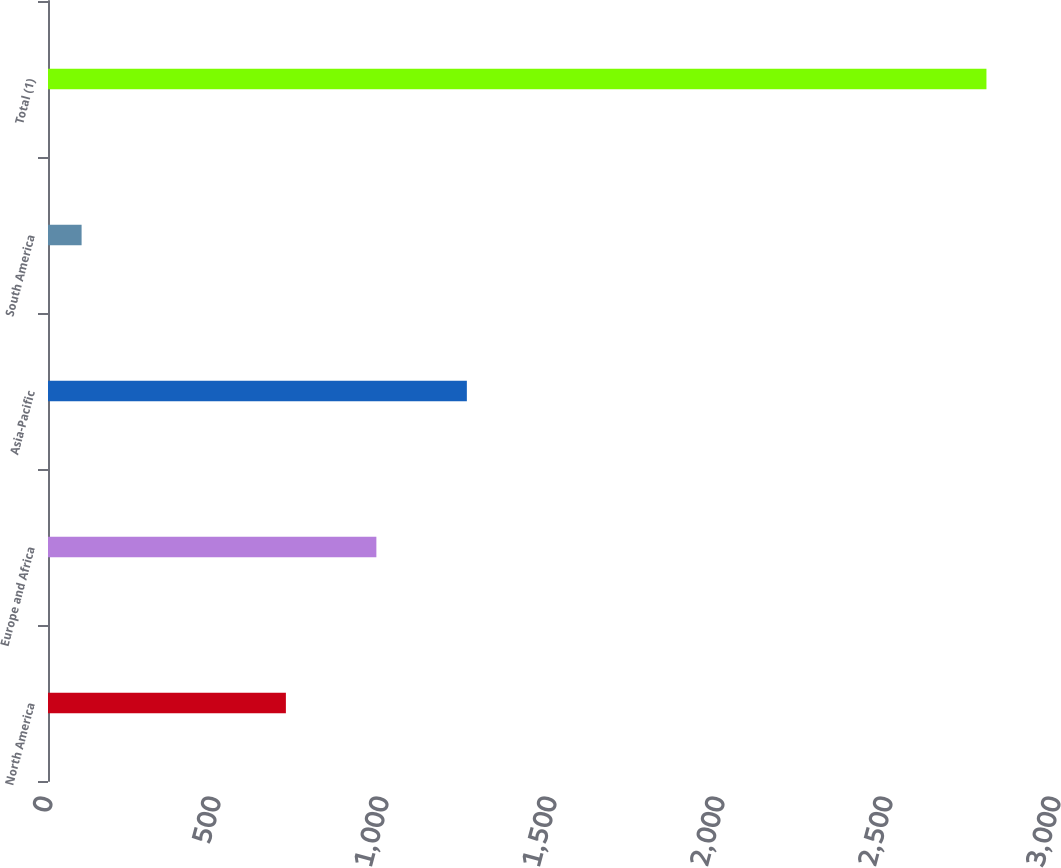<chart> <loc_0><loc_0><loc_500><loc_500><bar_chart><fcel>North America<fcel>Europe and Africa<fcel>Asia-Pacific<fcel>South America<fcel>Total (1)<nl><fcel>708<fcel>977.3<fcel>1246.6<fcel>100<fcel>2793<nl></chart> 